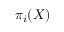Convert formula to latex. <formula><loc_0><loc_0><loc_500><loc_500>\pi _ { i } ( X )</formula> 